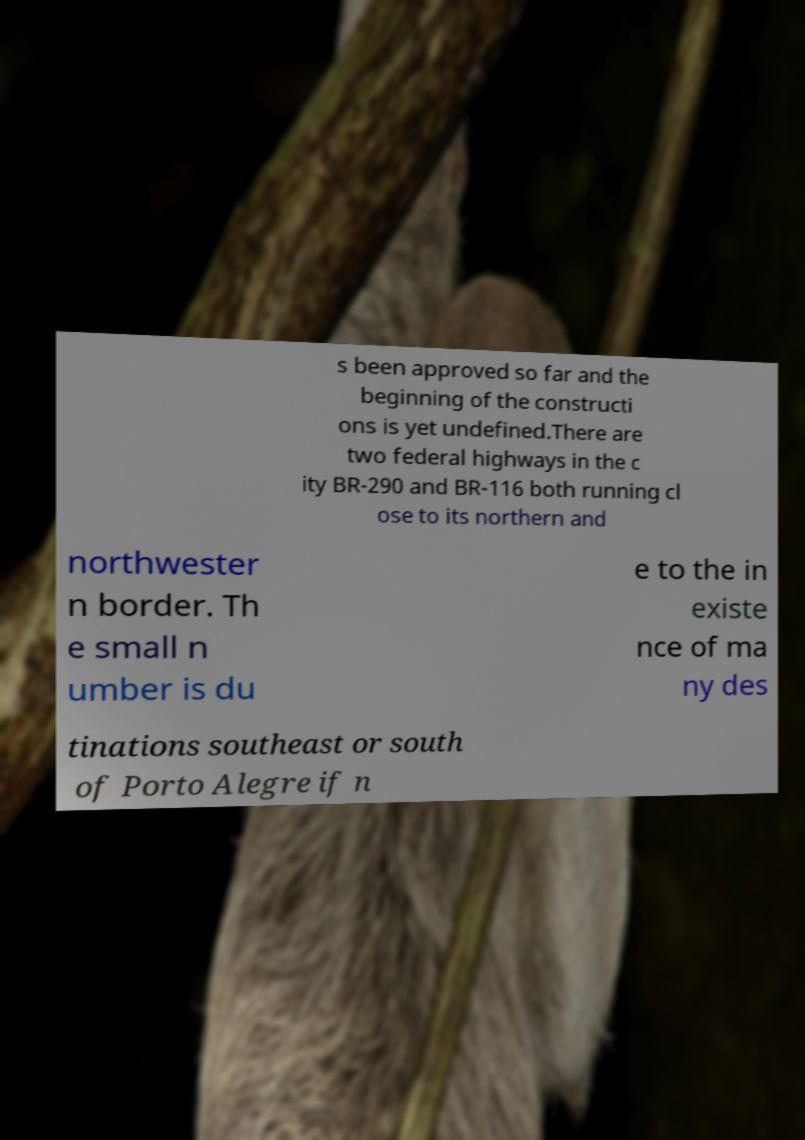There's text embedded in this image that I need extracted. Can you transcribe it verbatim? s been approved so far and the beginning of the constructi ons is yet undefined.There are two federal highways in the c ity BR-290 and BR-116 both running cl ose to its northern and northwester n border. Th e small n umber is du e to the in existe nce of ma ny des tinations southeast or south of Porto Alegre if n 